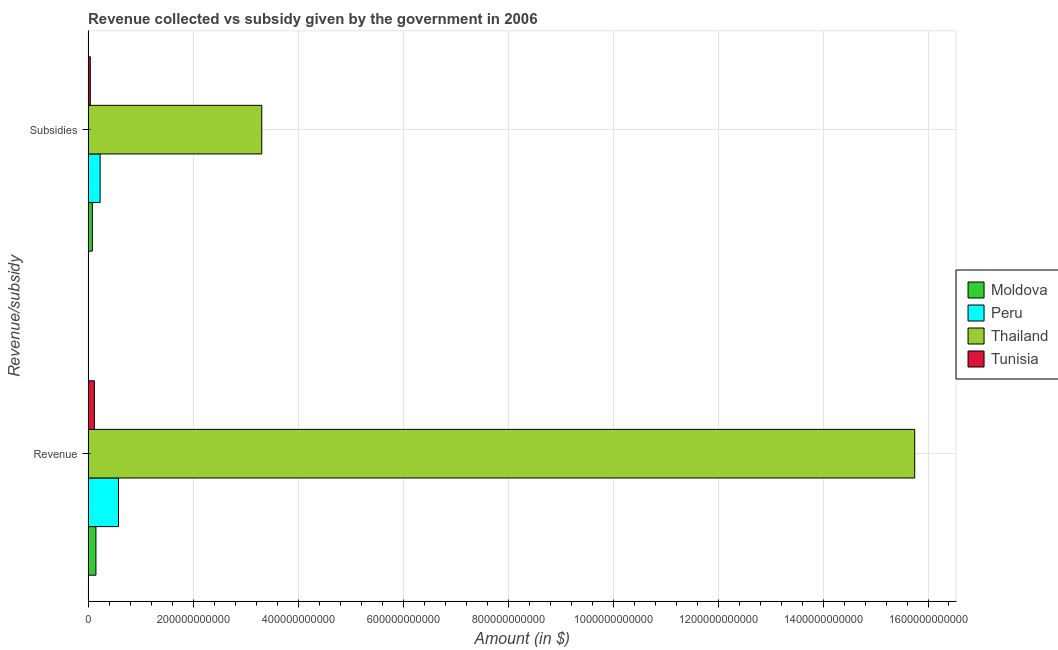Are the number of bars per tick equal to the number of legend labels?
Offer a very short reply. Yes. Are the number of bars on each tick of the Y-axis equal?
Provide a succinct answer. Yes. How many bars are there on the 1st tick from the bottom?
Provide a short and direct response. 4. What is the label of the 2nd group of bars from the top?
Give a very brief answer. Revenue. What is the amount of subsidies given in Moldova?
Your answer should be very brief. 8.06e+09. Across all countries, what is the maximum amount of revenue collected?
Your answer should be very brief. 1.57e+12. Across all countries, what is the minimum amount of revenue collected?
Your response must be concise. 1.21e+1. In which country was the amount of revenue collected maximum?
Provide a short and direct response. Thailand. In which country was the amount of subsidies given minimum?
Offer a very short reply. Tunisia. What is the total amount of revenue collected in the graph?
Keep it short and to the point. 1.66e+12. What is the difference between the amount of revenue collected in Peru and that in Thailand?
Offer a terse response. -1.52e+12. What is the difference between the amount of subsidies given in Peru and the amount of revenue collected in Moldova?
Your answer should be compact. 8.02e+09. What is the average amount of revenue collected per country?
Your answer should be compact. 4.15e+11. What is the difference between the amount of subsidies given and amount of revenue collected in Peru?
Provide a succinct answer. -3.50e+1. In how many countries, is the amount of subsidies given greater than 200000000000 $?
Offer a very short reply. 1. What is the ratio of the amount of subsidies given in Peru to that in Thailand?
Keep it short and to the point. 0.07. What does the 2nd bar from the top in Subsidies represents?
Make the answer very short. Thailand. What does the 4th bar from the bottom in Revenue represents?
Offer a very short reply. Tunisia. How many bars are there?
Your response must be concise. 8. Are all the bars in the graph horizontal?
Your answer should be compact. Yes. How many countries are there in the graph?
Give a very brief answer. 4. What is the difference between two consecutive major ticks on the X-axis?
Offer a terse response. 2.00e+11. Where does the legend appear in the graph?
Your response must be concise. Center right. How many legend labels are there?
Provide a succinct answer. 4. What is the title of the graph?
Make the answer very short. Revenue collected vs subsidy given by the government in 2006. Does "Guyana" appear as one of the legend labels in the graph?
Your response must be concise. No. What is the label or title of the X-axis?
Offer a very short reply. Amount (in $). What is the label or title of the Y-axis?
Make the answer very short. Revenue/subsidy. What is the Amount (in $) of Moldova in Revenue?
Make the answer very short. 1.49e+1. What is the Amount (in $) of Peru in Revenue?
Offer a very short reply. 5.79e+1. What is the Amount (in $) in Thailand in Revenue?
Offer a terse response. 1.57e+12. What is the Amount (in $) in Tunisia in Revenue?
Keep it short and to the point. 1.21e+1. What is the Amount (in $) of Moldova in Subsidies?
Ensure brevity in your answer.  8.06e+09. What is the Amount (in $) of Peru in Subsidies?
Your answer should be very brief. 2.29e+1. What is the Amount (in $) in Thailand in Subsidies?
Your response must be concise. 3.31e+11. What is the Amount (in $) of Tunisia in Subsidies?
Your answer should be very brief. 4.20e+09. Across all Revenue/subsidy, what is the maximum Amount (in $) of Moldova?
Your response must be concise. 1.49e+1. Across all Revenue/subsidy, what is the maximum Amount (in $) in Peru?
Offer a terse response. 5.79e+1. Across all Revenue/subsidy, what is the maximum Amount (in $) in Thailand?
Ensure brevity in your answer.  1.57e+12. Across all Revenue/subsidy, what is the maximum Amount (in $) of Tunisia?
Provide a short and direct response. 1.21e+1. Across all Revenue/subsidy, what is the minimum Amount (in $) in Moldova?
Keep it short and to the point. 8.06e+09. Across all Revenue/subsidy, what is the minimum Amount (in $) in Peru?
Offer a very short reply. 2.29e+1. Across all Revenue/subsidy, what is the minimum Amount (in $) in Thailand?
Offer a very short reply. 3.31e+11. Across all Revenue/subsidy, what is the minimum Amount (in $) of Tunisia?
Provide a short and direct response. 4.20e+09. What is the total Amount (in $) in Moldova in the graph?
Your response must be concise. 2.30e+1. What is the total Amount (in $) in Peru in the graph?
Offer a very short reply. 8.08e+1. What is the total Amount (in $) in Thailand in the graph?
Give a very brief answer. 1.91e+12. What is the total Amount (in $) of Tunisia in the graph?
Keep it short and to the point. 1.63e+1. What is the difference between the Amount (in $) in Moldova in Revenue and that in Subsidies?
Your answer should be compact. 6.84e+09. What is the difference between the Amount (in $) in Peru in Revenue and that in Subsidies?
Your response must be concise. 3.50e+1. What is the difference between the Amount (in $) of Thailand in Revenue and that in Subsidies?
Ensure brevity in your answer.  1.24e+12. What is the difference between the Amount (in $) in Tunisia in Revenue and that in Subsidies?
Ensure brevity in your answer.  7.88e+09. What is the difference between the Amount (in $) of Moldova in Revenue and the Amount (in $) of Peru in Subsidies?
Keep it short and to the point. -8.02e+09. What is the difference between the Amount (in $) in Moldova in Revenue and the Amount (in $) in Thailand in Subsidies?
Offer a terse response. -3.16e+11. What is the difference between the Amount (in $) of Moldova in Revenue and the Amount (in $) of Tunisia in Subsidies?
Your answer should be very brief. 1.07e+1. What is the difference between the Amount (in $) of Peru in Revenue and the Amount (in $) of Thailand in Subsidies?
Your answer should be very brief. -2.73e+11. What is the difference between the Amount (in $) of Peru in Revenue and the Amount (in $) of Tunisia in Subsidies?
Offer a very short reply. 5.37e+1. What is the difference between the Amount (in $) in Thailand in Revenue and the Amount (in $) in Tunisia in Subsidies?
Ensure brevity in your answer.  1.57e+12. What is the average Amount (in $) of Moldova per Revenue/subsidy?
Offer a terse response. 1.15e+1. What is the average Amount (in $) of Peru per Revenue/subsidy?
Offer a terse response. 4.04e+1. What is the average Amount (in $) in Thailand per Revenue/subsidy?
Your response must be concise. 9.53e+11. What is the average Amount (in $) in Tunisia per Revenue/subsidy?
Offer a terse response. 8.14e+09. What is the difference between the Amount (in $) in Moldova and Amount (in $) in Peru in Revenue?
Offer a very short reply. -4.30e+1. What is the difference between the Amount (in $) of Moldova and Amount (in $) of Thailand in Revenue?
Provide a short and direct response. -1.56e+12. What is the difference between the Amount (in $) in Moldova and Amount (in $) in Tunisia in Revenue?
Provide a succinct answer. 2.82e+09. What is the difference between the Amount (in $) of Peru and Amount (in $) of Thailand in Revenue?
Your answer should be very brief. -1.52e+12. What is the difference between the Amount (in $) of Peru and Amount (in $) of Tunisia in Revenue?
Your answer should be compact. 4.58e+1. What is the difference between the Amount (in $) in Thailand and Amount (in $) in Tunisia in Revenue?
Provide a succinct answer. 1.56e+12. What is the difference between the Amount (in $) in Moldova and Amount (in $) in Peru in Subsidies?
Your response must be concise. -1.49e+1. What is the difference between the Amount (in $) in Moldova and Amount (in $) in Thailand in Subsidies?
Ensure brevity in your answer.  -3.23e+11. What is the difference between the Amount (in $) in Moldova and Amount (in $) in Tunisia in Subsidies?
Offer a terse response. 3.86e+09. What is the difference between the Amount (in $) of Peru and Amount (in $) of Thailand in Subsidies?
Provide a succinct answer. -3.08e+11. What is the difference between the Amount (in $) in Peru and Amount (in $) in Tunisia in Subsidies?
Your answer should be compact. 1.87e+1. What is the difference between the Amount (in $) in Thailand and Amount (in $) in Tunisia in Subsidies?
Provide a succinct answer. 3.27e+11. What is the ratio of the Amount (in $) of Moldova in Revenue to that in Subsidies?
Keep it short and to the point. 1.85. What is the ratio of the Amount (in $) in Peru in Revenue to that in Subsidies?
Your response must be concise. 2.53. What is the ratio of the Amount (in $) of Thailand in Revenue to that in Subsidies?
Ensure brevity in your answer.  4.76. What is the ratio of the Amount (in $) in Tunisia in Revenue to that in Subsidies?
Provide a short and direct response. 2.87. What is the difference between the highest and the second highest Amount (in $) of Moldova?
Provide a succinct answer. 6.84e+09. What is the difference between the highest and the second highest Amount (in $) of Peru?
Make the answer very short. 3.50e+1. What is the difference between the highest and the second highest Amount (in $) in Thailand?
Keep it short and to the point. 1.24e+12. What is the difference between the highest and the second highest Amount (in $) in Tunisia?
Your answer should be very brief. 7.88e+09. What is the difference between the highest and the lowest Amount (in $) of Moldova?
Give a very brief answer. 6.84e+09. What is the difference between the highest and the lowest Amount (in $) of Peru?
Give a very brief answer. 3.50e+1. What is the difference between the highest and the lowest Amount (in $) of Thailand?
Provide a succinct answer. 1.24e+12. What is the difference between the highest and the lowest Amount (in $) in Tunisia?
Offer a very short reply. 7.88e+09. 